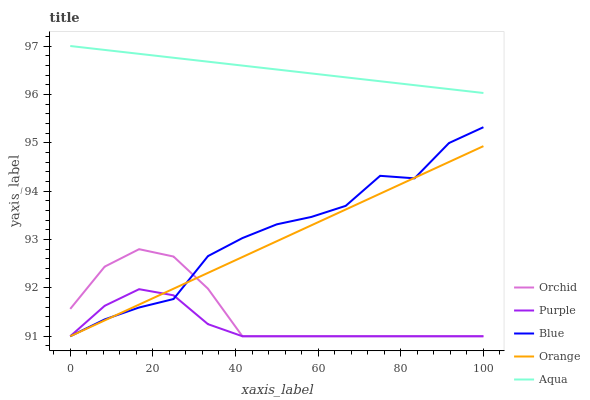Does Blue have the minimum area under the curve?
Answer yes or no. No. Does Blue have the maximum area under the curve?
Answer yes or no. No. Is Orange the smoothest?
Answer yes or no. No. Is Orange the roughest?
Answer yes or no. No. Does Aqua have the lowest value?
Answer yes or no. No. Does Blue have the highest value?
Answer yes or no. No. Is Blue less than Aqua?
Answer yes or no. Yes. Is Aqua greater than Orange?
Answer yes or no. Yes. Does Blue intersect Aqua?
Answer yes or no. No. 